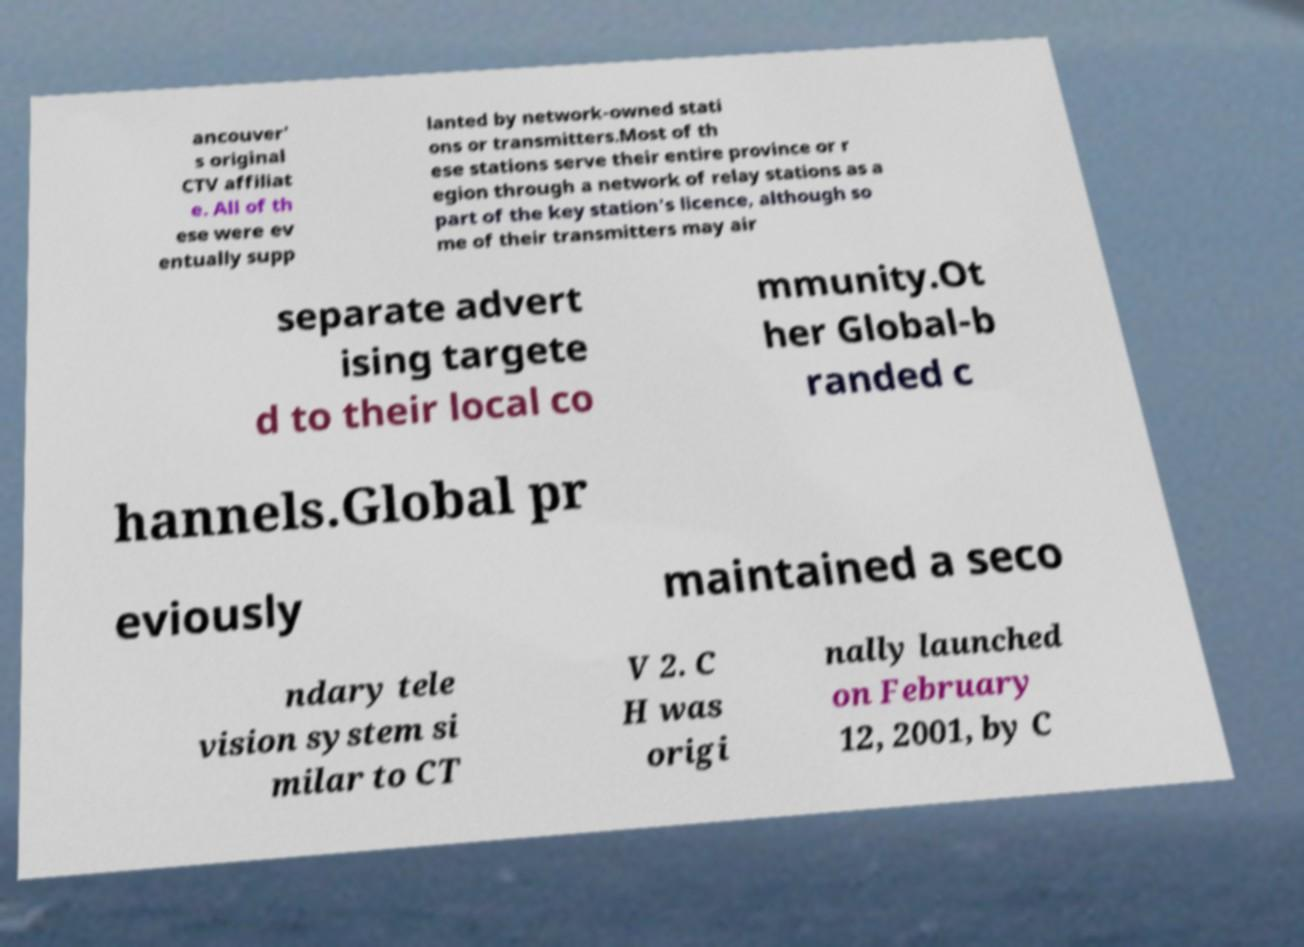Can you read and provide the text displayed in the image?This photo seems to have some interesting text. Can you extract and type it out for me? ancouver' s original CTV affiliat e. All of th ese were ev entually supp lanted by network-owned stati ons or transmitters.Most of th ese stations serve their entire province or r egion through a network of relay stations as a part of the key station's licence, although so me of their transmitters may air separate advert ising targete d to their local co mmunity.Ot her Global-b randed c hannels.Global pr eviously maintained a seco ndary tele vision system si milar to CT V 2. C H was origi nally launched on February 12, 2001, by C 